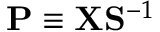<formula> <loc_0><loc_0><loc_500><loc_500>{ P } \equiv X { S } ^ { - 1 }</formula> 